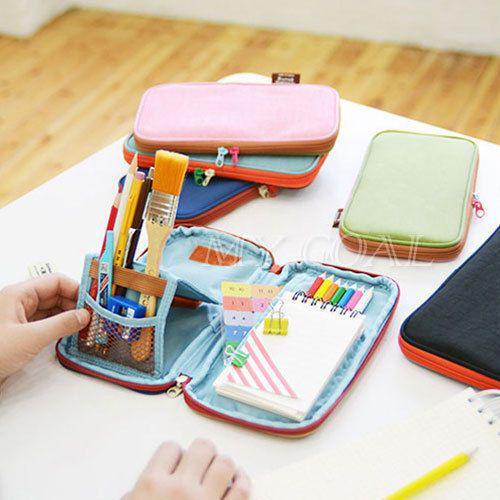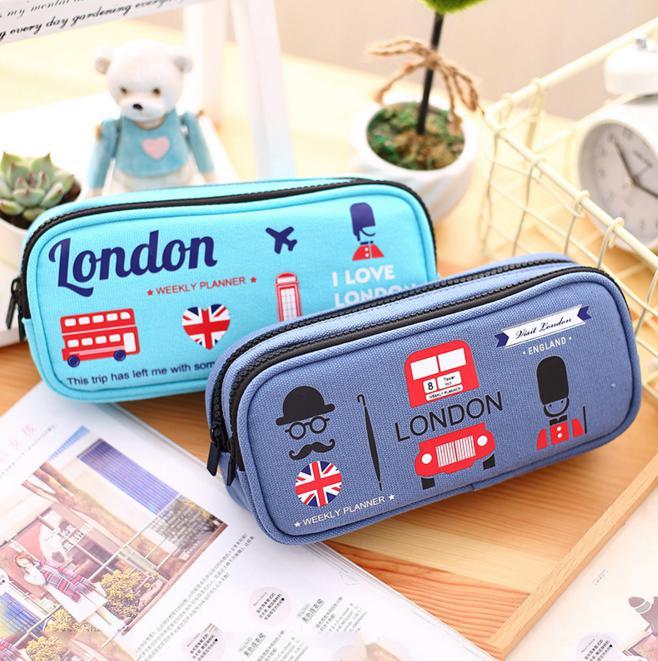The first image is the image on the left, the second image is the image on the right. Evaluate the accuracy of this statement regarding the images: "The right image depicts at least three pencil cases.". Is it true? Answer yes or no. No. 